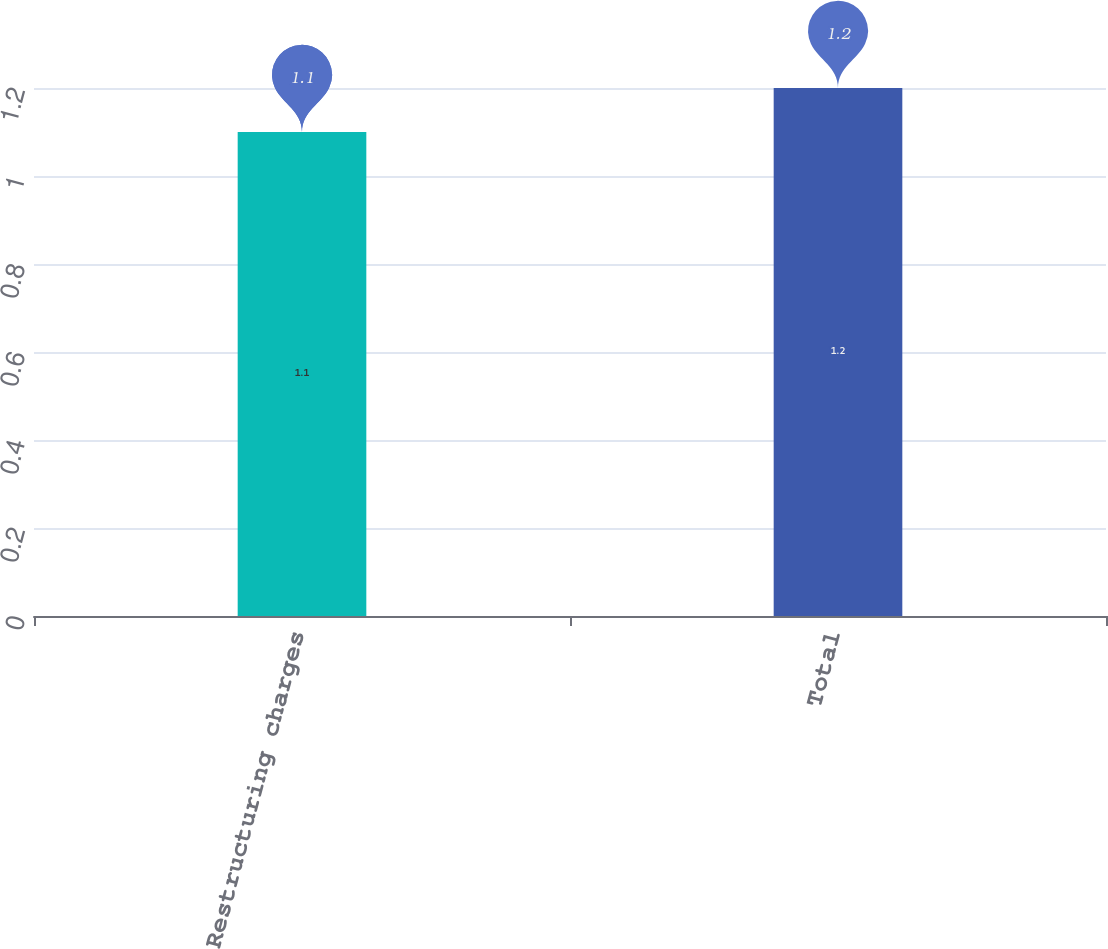Convert chart to OTSL. <chart><loc_0><loc_0><loc_500><loc_500><bar_chart><fcel>Restructuring charges<fcel>Total<nl><fcel>1.1<fcel>1.2<nl></chart> 